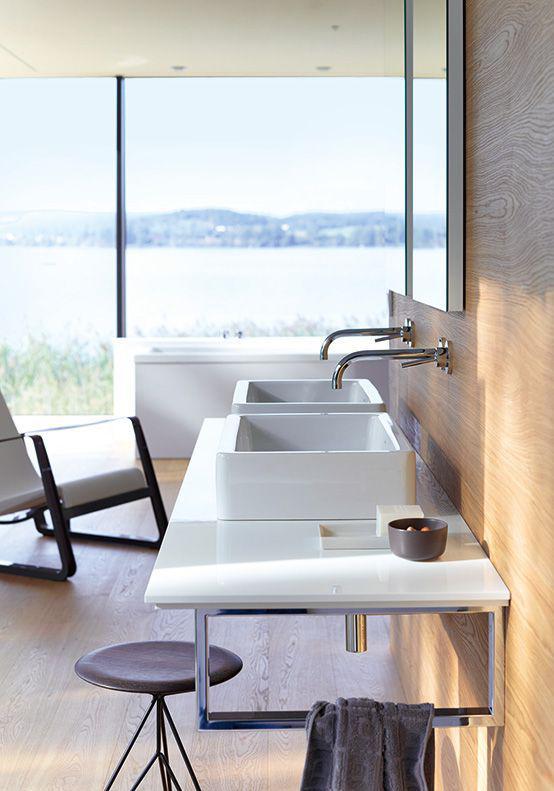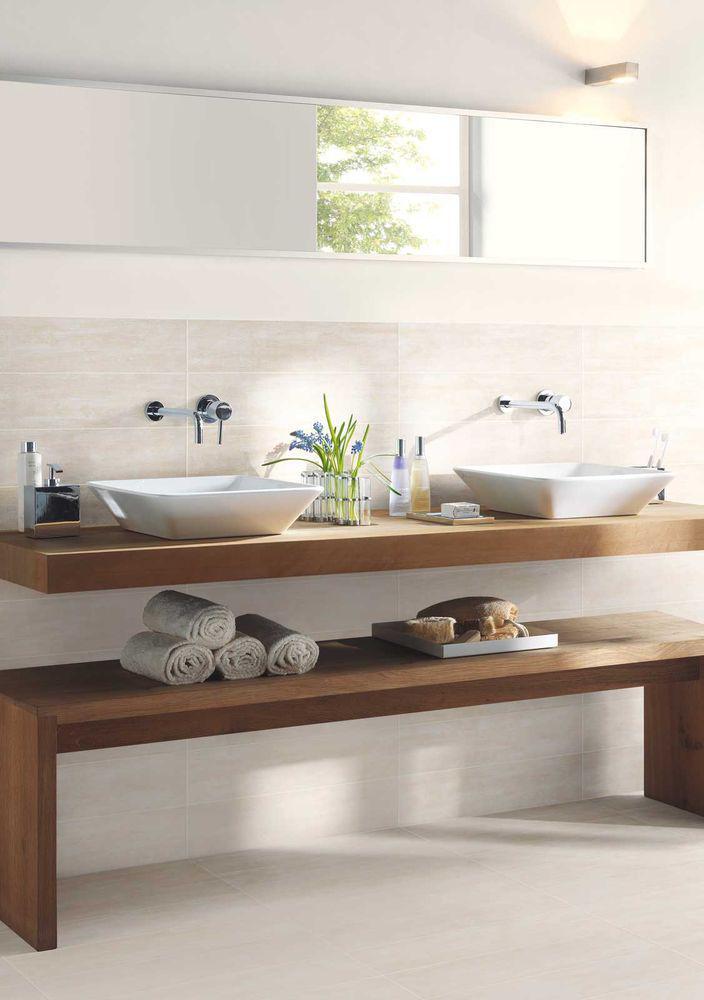The first image is the image on the left, the second image is the image on the right. For the images displayed, is the sentence "A bathroom features a toilet to the right of the sink." factually correct? Answer yes or no. No. The first image is the image on the left, the second image is the image on the right. Evaluate the accuracy of this statement regarding the images: "There is a rectangular toilet in one of the images.". Is it true? Answer yes or no. No. 